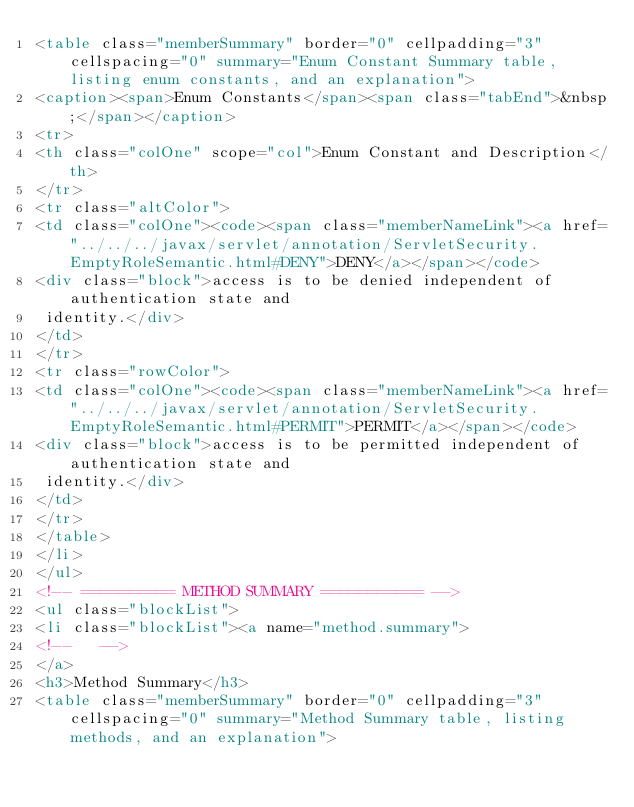Convert code to text. <code><loc_0><loc_0><loc_500><loc_500><_HTML_><table class="memberSummary" border="0" cellpadding="3" cellspacing="0" summary="Enum Constant Summary table, listing enum constants, and an explanation">
<caption><span>Enum Constants</span><span class="tabEnd">&nbsp;</span></caption>
<tr>
<th class="colOne" scope="col">Enum Constant and Description</th>
</tr>
<tr class="altColor">
<td class="colOne"><code><span class="memberNameLink"><a href="../../../javax/servlet/annotation/ServletSecurity.EmptyRoleSemantic.html#DENY">DENY</a></span></code>
<div class="block">access is to be denied independent of authentication state and
 identity.</div>
</td>
</tr>
<tr class="rowColor">
<td class="colOne"><code><span class="memberNameLink"><a href="../../../javax/servlet/annotation/ServletSecurity.EmptyRoleSemantic.html#PERMIT">PERMIT</a></span></code>
<div class="block">access is to be permitted independent of authentication state and
 identity.</div>
</td>
</tr>
</table>
</li>
</ul>
<!-- ========== METHOD SUMMARY =========== -->
<ul class="blockList">
<li class="blockList"><a name="method.summary">
<!--   -->
</a>
<h3>Method Summary</h3>
<table class="memberSummary" border="0" cellpadding="3" cellspacing="0" summary="Method Summary table, listing methods, and an explanation"></code> 